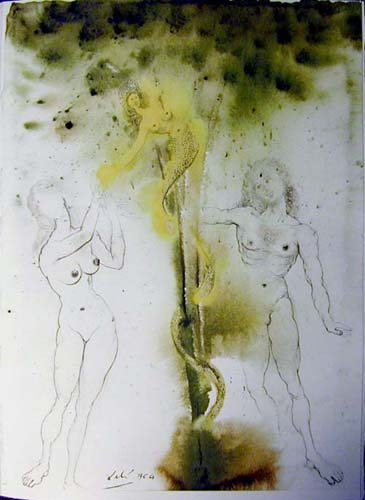Can you describe the main features of this image for me? The image features a captivating surrealistic composition with three figures that stand out prominently. Each figure is rendered with delicate, sketch-like black lines against a dreamy backdrop of green and yellow hues, imbuing the scene with a ghostly or ethereal quality. The central figure grasps a sinuous object, possibly a vine, which adds to the mystique of the setting. The background is speckled with dark spots, contributing to the depth and textured appearance of the artwork. The figures' expressions and poses invite various interpretations, possibly representing themes of connection, nature, or human emotion, encapsulating the quintessence of surreal art by challenging the boundaries of reality and dream. 